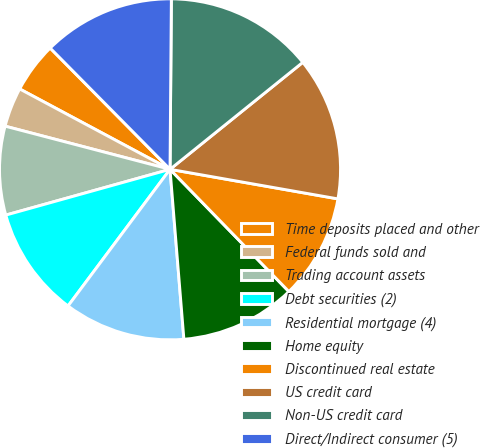Convert chart. <chart><loc_0><loc_0><loc_500><loc_500><pie_chart><fcel>Time deposits placed and other<fcel>Federal funds sold and<fcel>Trading account assets<fcel>Debt securities (2)<fcel>Residential mortgage (4)<fcel>Home equity<fcel>Discontinued real estate<fcel>US credit card<fcel>Non-US credit card<fcel>Direct/Indirect consumer (5)<nl><fcel>4.78%<fcel>3.74%<fcel>8.4%<fcel>10.47%<fcel>11.5%<fcel>10.98%<fcel>9.95%<fcel>13.57%<fcel>14.08%<fcel>12.53%<nl></chart> 